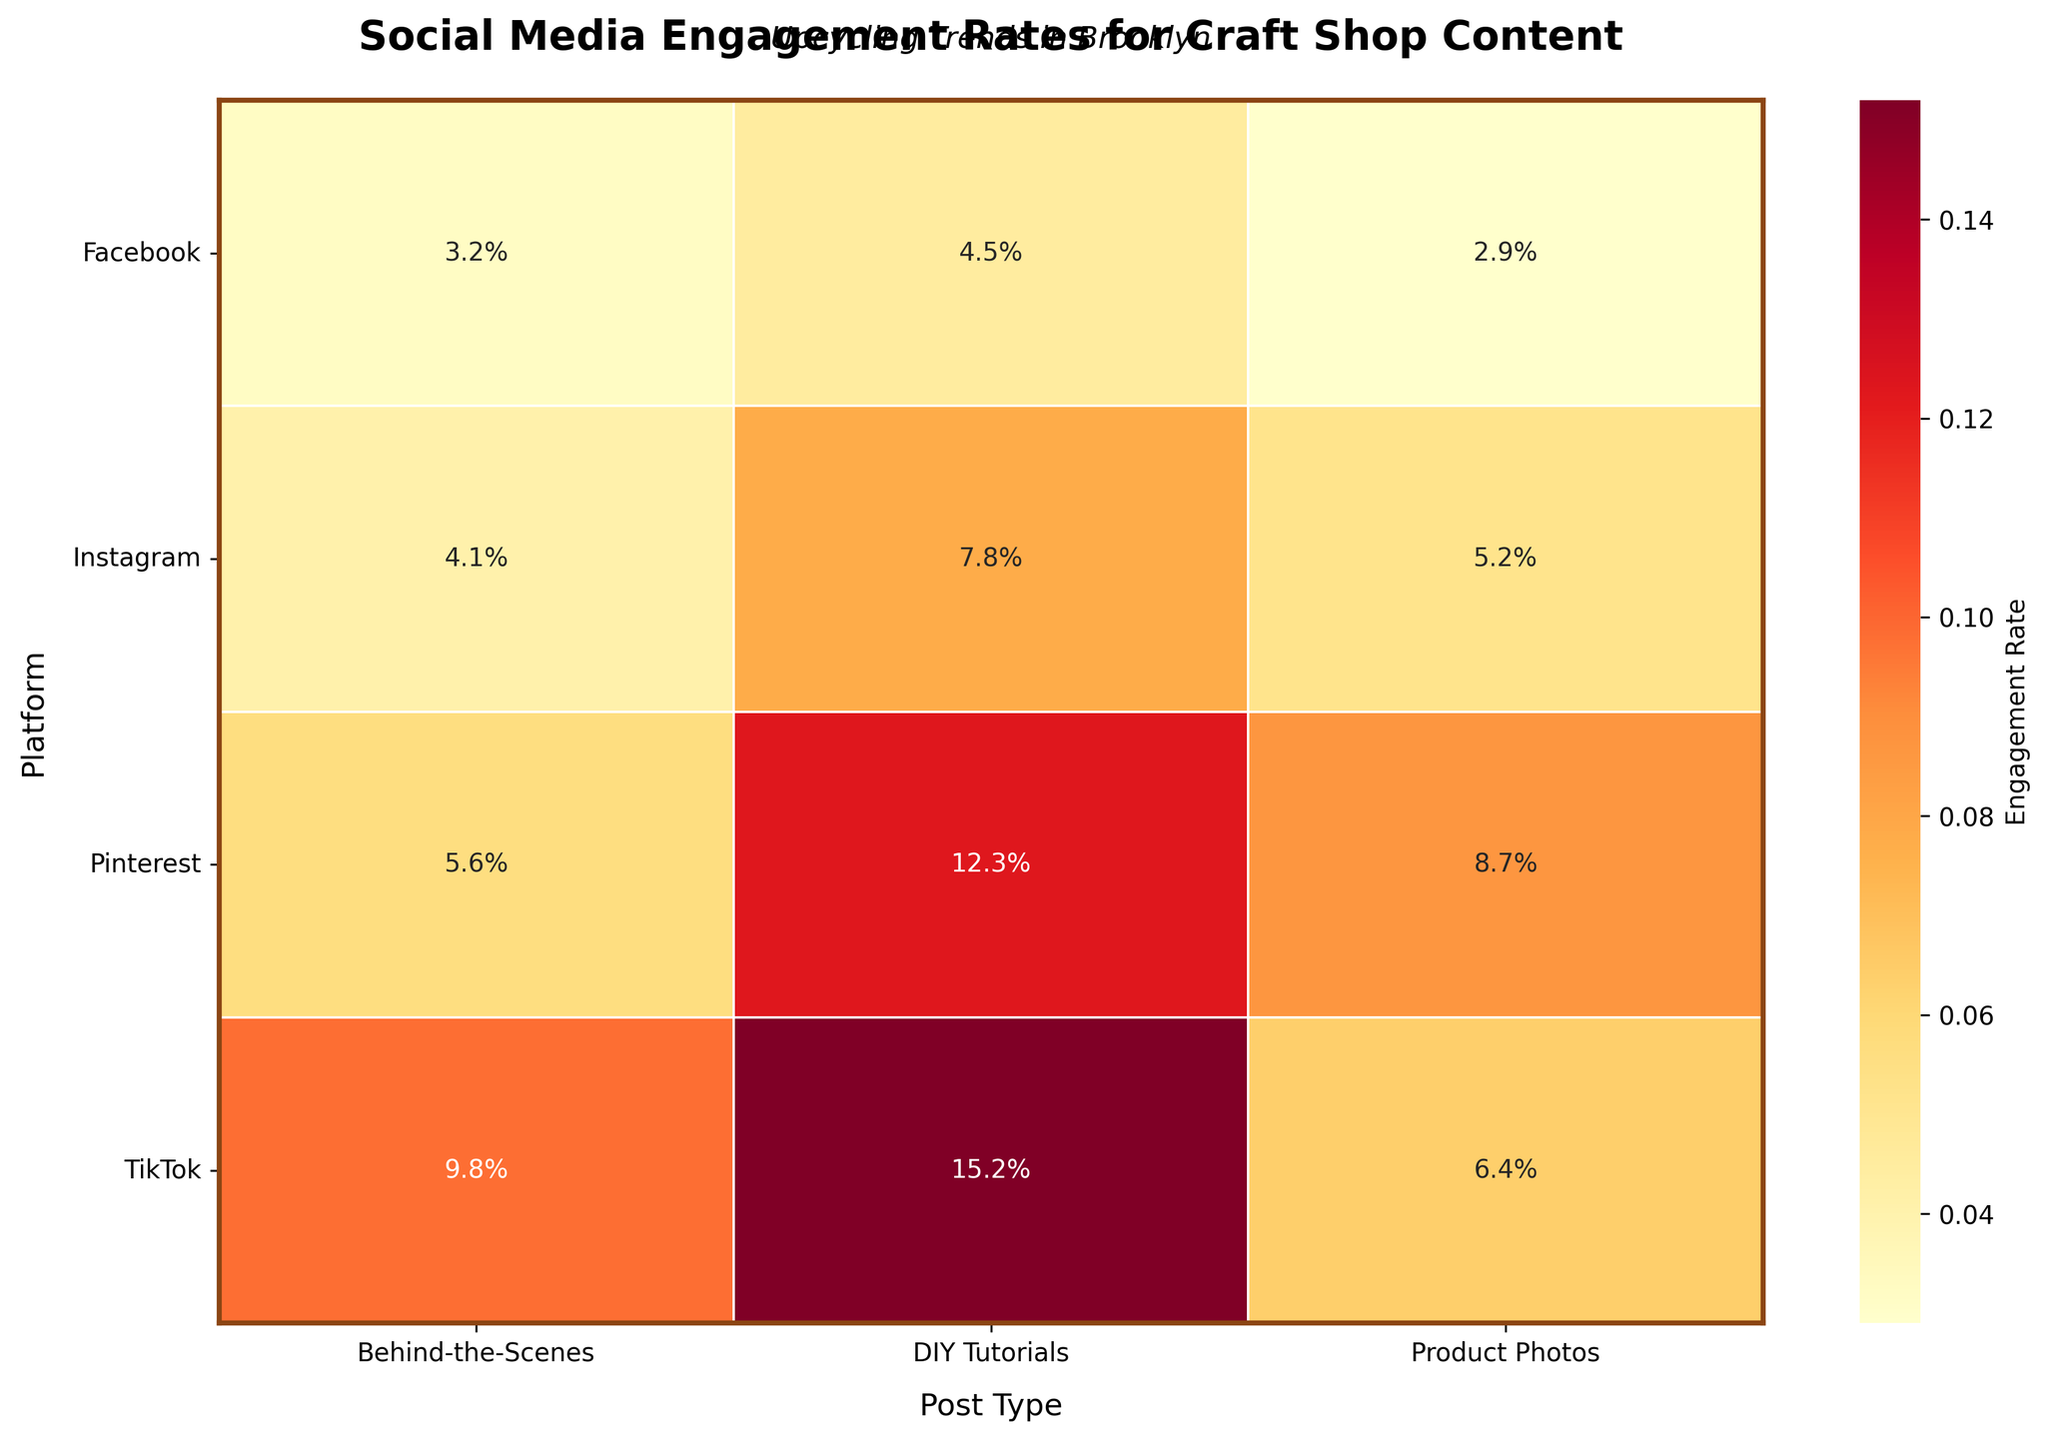Which platform has the highest engagement rate for DIY Tutorials? Look at the values under the "DIY Tutorials" column and identify the platform with the highest percentage. The highest rate (15.2%) is for TikTok.
Answer: TikTok What is the average engagement rate for Product Photos across all platforms? Identify Product Photos' rates (5.2%, 2.9%, 8.7%, 6.4%), sum them up (23.2%), and divide by the number of platforms (4). Average rate = 23.2% / 4 = 5.8%.
Answer: 5.8% Which post type consistently shows the highest engagement rates across platforms? Compare engagement rates for Product Photos, DIY Tutorials, and Behind-the-Scenes across all platforms. DIY Tutorials have the highest rates in almost all cases: Instagram (7.8%), Facebook (4.5%), Pinterest (12.3%), TikTok (15.2%).
Answer: DIY Tutorials How does the engagement rate for Pinterest Product Photos compare with TikTok Behind-the-Scenes? Identify and compare these values from the figure: Pinterest Product Photos (8.7%) and TikTok Behind-the-Scenes (9.8%). TikTok Behind-the-Scenes has a higher rate.
Answer: TikTok Behind-the-Scenes is higher For which platform does Behind-the-Scenes content perform better than Product Photos? Compare the values for Behind-the-Scenes and Product Photos within each platform: Instagram (4.1% < 5.2%), Facebook (3.2% > 2.9%), Pinterest (5.6% < 8.7%), TikTok (9.8% > 6.4%). Facebook and TikTok meet this condition.
Answer: Facebook and TikTok What is the sum of all engagement rates for Instagram? Sum the engagement rates for Instagram (5.2%, 7.8%, 4.1%). Sum = 5.2 + 7.8 + 4.1 = 17.1%.
Answer: 17.1% Which post type has the lowest engagement rate on Facebook? Compare the engagement rates for different post types on Facebook: Product Photos (2.9%), DIY Tutorials (4.5%), Behind-the-Scenes (3.2%). Product Photos have the lowest rate.
Answer: Product Photos What is the difference in engagement rates between Pinterest DIY Tutorials and Instagram DIY Tutorials? Identify the engagement rates for Pinterest DIY Tutorials (12.3%) and Instagram DIY Tutorials (7.8%), then find the difference (12.3% - 7.8% = 4.5%).
Answer: 4.5% Which has a higher engagement rate: Instagram Behind-the-Scenes or Facebook DIY Tutorials? Compare these values from the figure: Instagram Behind-the-Scenes (4.1%) and Facebook DIY Tutorials (4.5%). Facebook DIY Tutorials are higher.
Answer: Facebook DIY Tutorials What is the total engagement rate for TikTok across all post types? Sum the engagement rates for TikTok (6.4%, 15.2%, 9.8%). Sum = 6.4 + 15.2 + 9.8 = 31.4%.
Answer: 31.4% 